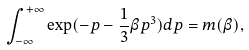<formula> <loc_0><loc_0><loc_500><loc_500>\int _ { - \infty } ^ { + \infty } \exp ( - p - \frac { 1 } { 3 } \beta p ^ { 3 } ) d p = m ( \beta ) ,</formula> 